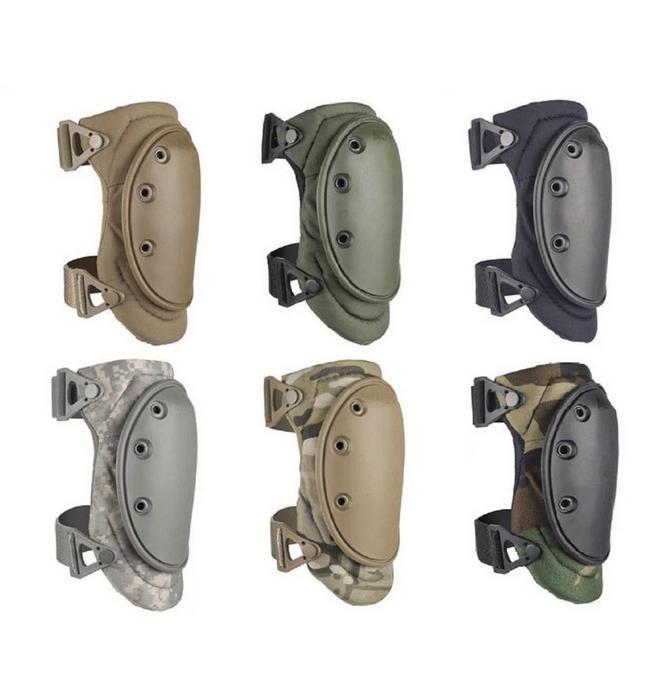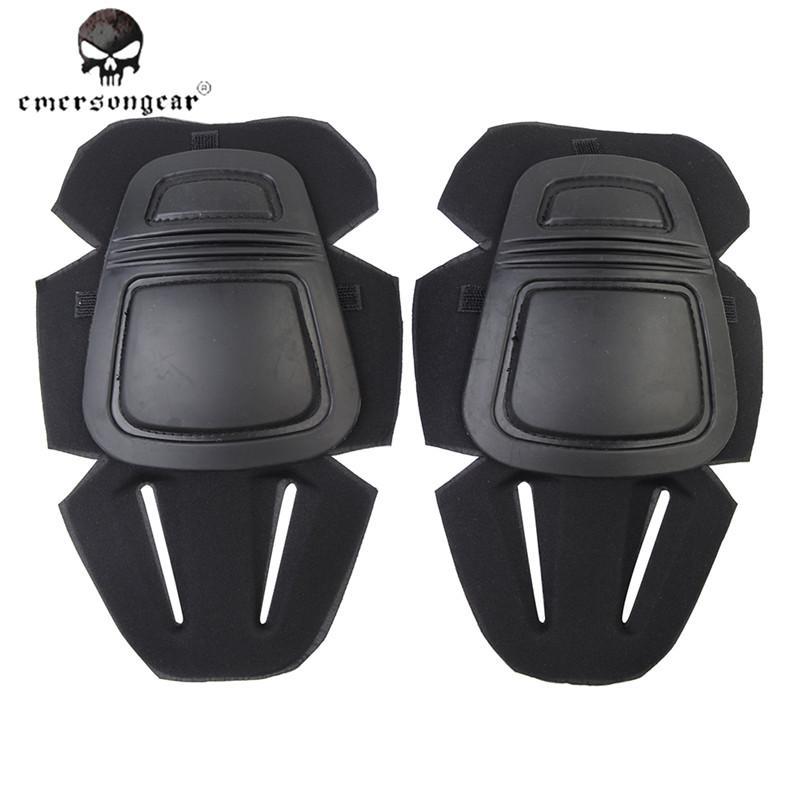The first image is the image on the left, the second image is the image on the right. Assess this claim about the two images: "The combined images contain eight protective pads.". Correct or not? Answer yes or no. Yes. The first image is the image on the left, the second image is the image on the right. Considering the images on both sides, is "There are more pads in the image on the left than in the image on the right." valid? Answer yes or no. Yes. 